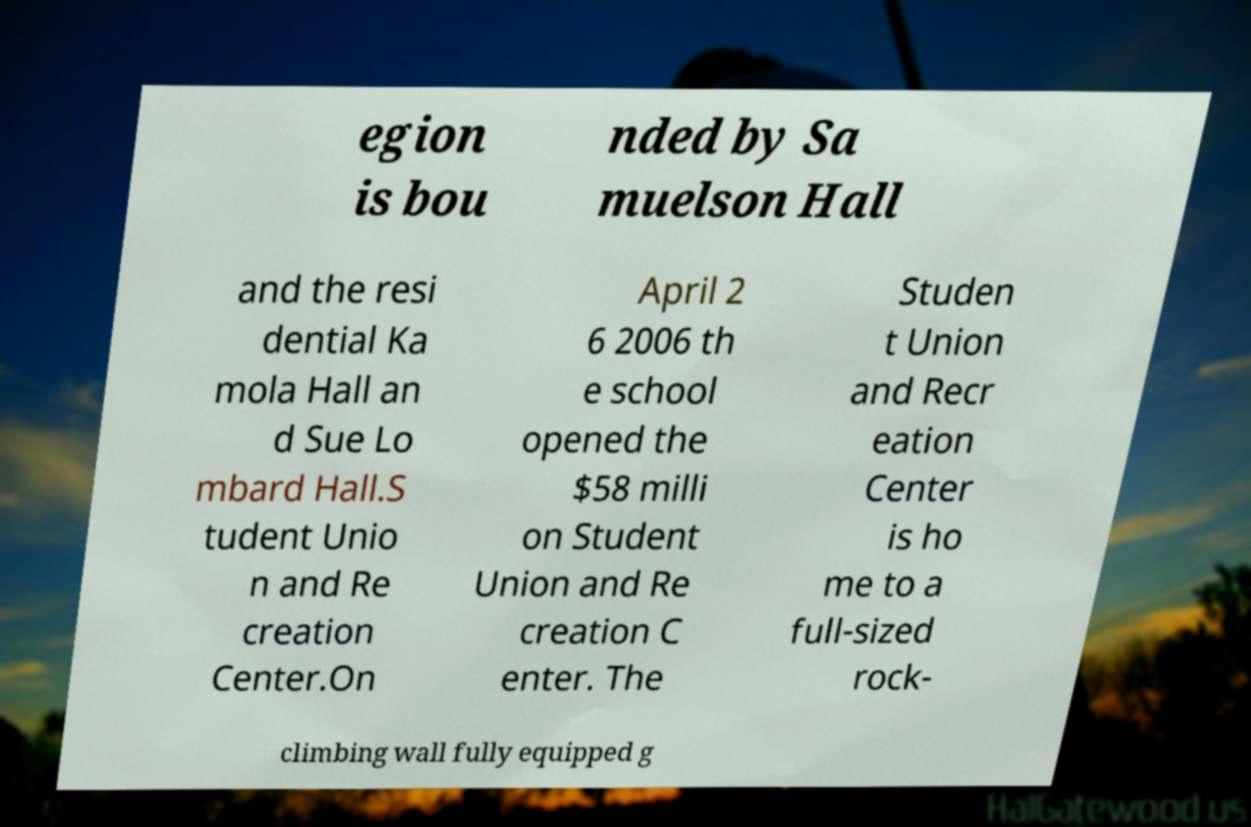For documentation purposes, I need the text within this image transcribed. Could you provide that? egion is bou nded by Sa muelson Hall and the resi dential Ka mola Hall an d Sue Lo mbard Hall.S tudent Unio n and Re creation Center.On April 2 6 2006 th e school opened the $58 milli on Student Union and Re creation C enter. The Studen t Union and Recr eation Center is ho me to a full-sized rock- climbing wall fully equipped g 